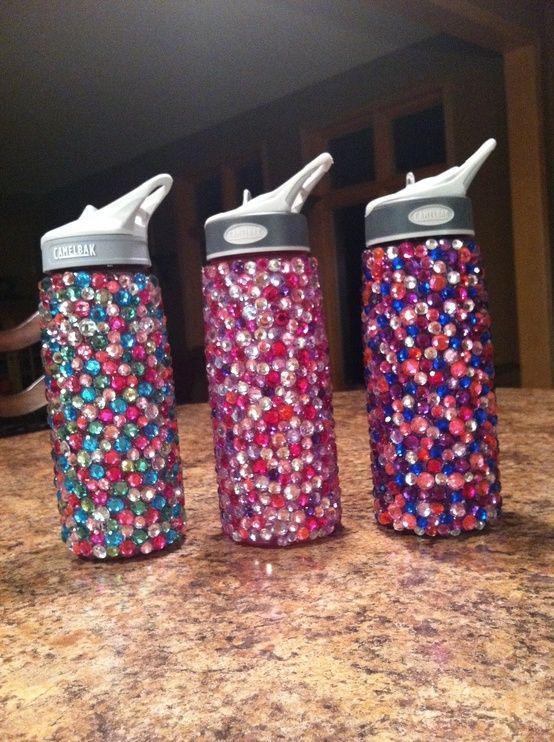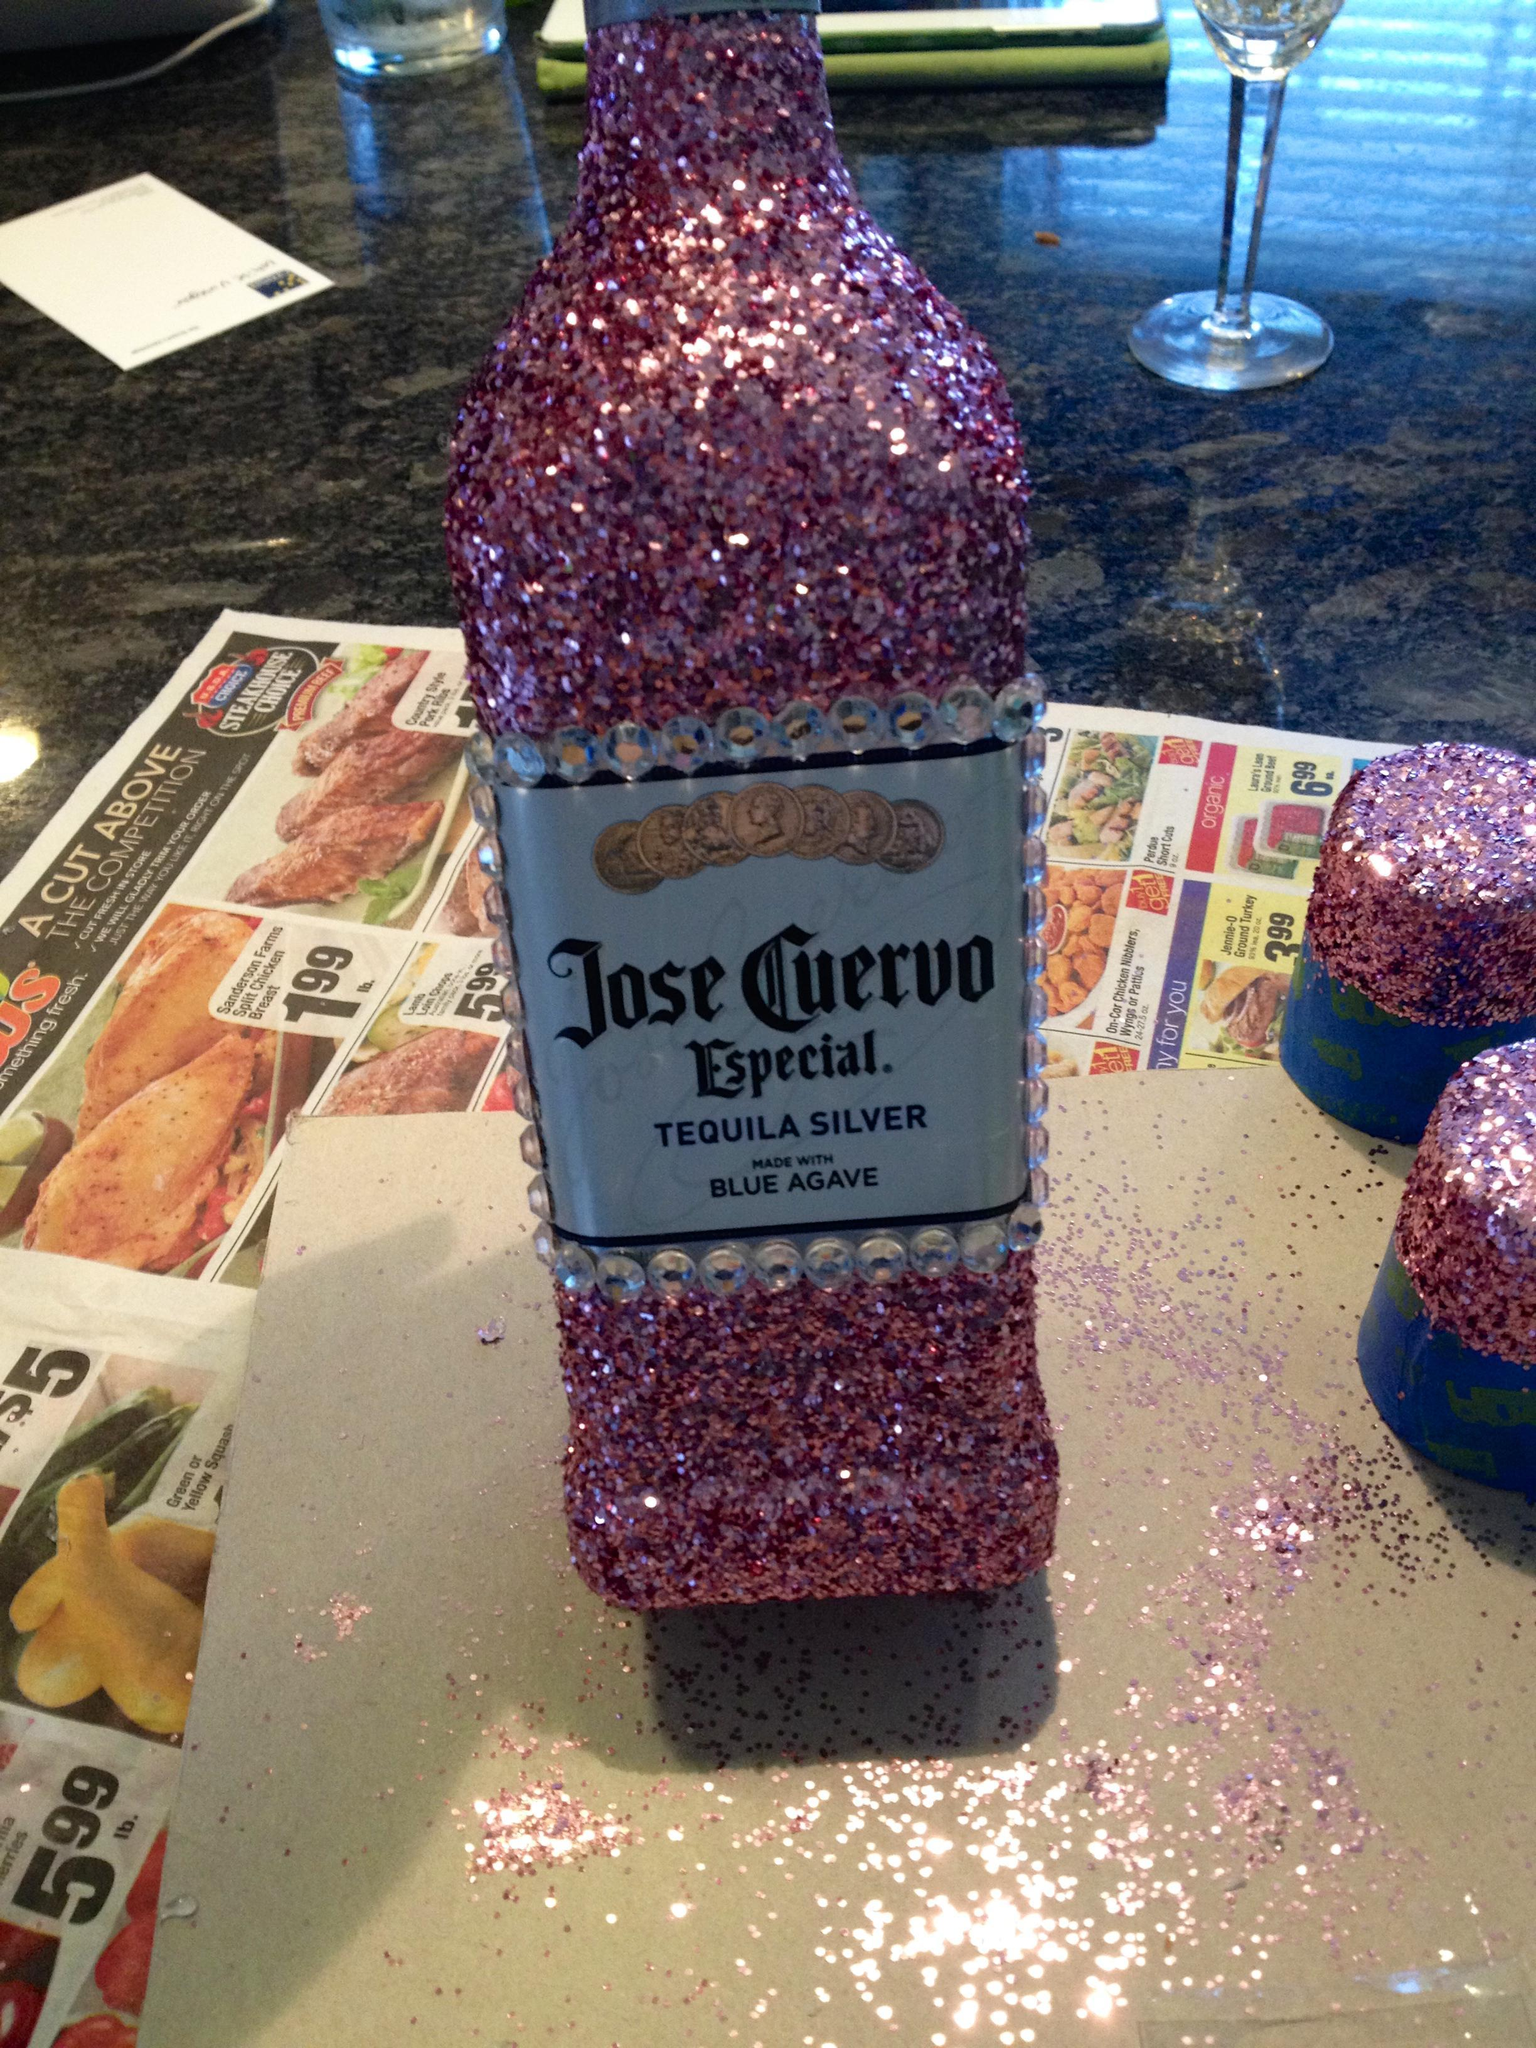The first image is the image on the left, the second image is the image on the right. Evaluate the accuracy of this statement regarding the images: "One image features a horizontal row of four water bottles with straps on them and different designs on their fronts.". Is it true? Answer yes or no. No. The first image is the image on the left, the second image is the image on the right. For the images displayed, is the sentence "In one of the images, four water bottles with carrying straps are sitting in a row on a table." factually correct? Answer yes or no. No. 